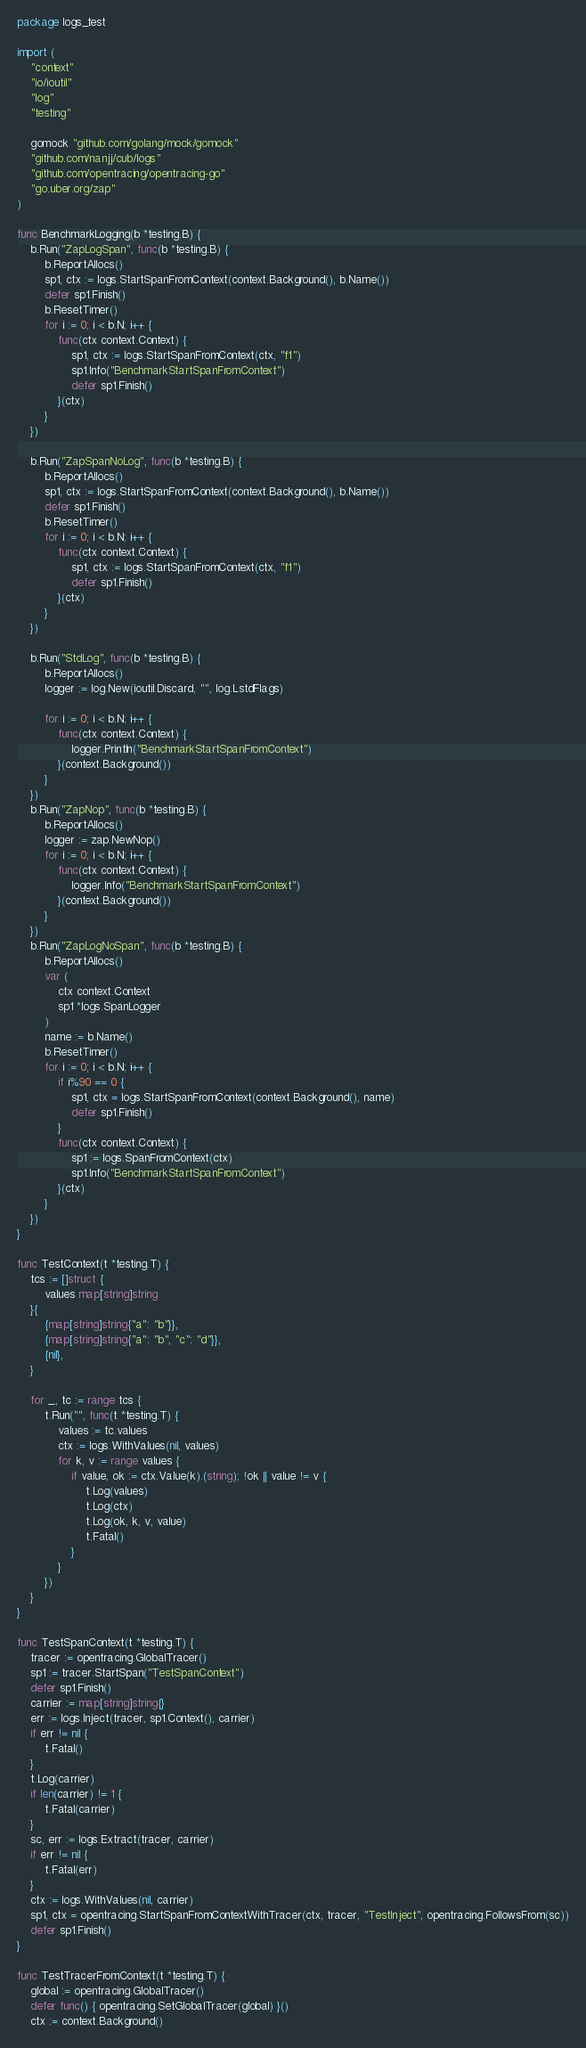Convert code to text. <code><loc_0><loc_0><loc_500><loc_500><_Go_>package logs_test

import (
	"context"
	"io/ioutil"
	"log"
	"testing"

	gomock "github.com/golang/mock/gomock"
	"github.com/nanjj/cub/logs"
	"github.com/opentracing/opentracing-go"
	"go.uber.org/zap"
)

func BenchmarkLogging(b *testing.B) {
	b.Run("ZapLogSpan", func(b *testing.B) {
		b.ReportAllocs()
		sp1, ctx := logs.StartSpanFromContext(context.Background(), b.Name())
		defer sp1.Finish()
		b.ResetTimer()
		for i := 0; i < b.N; i++ {
			func(ctx context.Context) {
				sp1, ctx := logs.StartSpanFromContext(ctx, "f1")
				sp1.Info("BenchmarkStartSpanFromContext")
				defer sp1.Finish()
			}(ctx)
		}
	})

	b.Run("ZapSpanNoLog", func(b *testing.B) {
		b.ReportAllocs()
		sp1, ctx := logs.StartSpanFromContext(context.Background(), b.Name())
		defer sp1.Finish()
		b.ResetTimer()
		for i := 0; i < b.N; i++ {
			func(ctx context.Context) {
				sp1, ctx := logs.StartSpanFromContext(ctx, "f1")
				defer sp1.Finish()
			}(ctx)
		}
	})

	b.Run("StdLog", func(b *testing.B) {
		b.ReportAllocs()
		logger := log.New(ioutil.Discard, "", log.LstdFlags)

		for i := 0; i < b.N; i++ {
			func(ctx context.Context) {
				logger.Println("BenchmarkStartSpanFromContext")
			}(context.Background())
		}
	})
	b.Run("ZapNop", func(b *testing.B) {
		b.ReportAllocs()
		logger := zap.NewNop()
		for i := 0; i < b.N; i++ {
			func(ctx context.Context) {
				logger.Info("BenchmarkStartSpanFromContext")
			}(context.Background())
		}
	})
	b.Run("ZapLogNoSpan", func(b *testing.B) {
		b.ReportAllocs()
		var (
			ctx context.Context
			sp1 *logs.SpanLogger
		)
		name := b.Name()
		b.ResetTimer()
		for i := 0; i < b.N; i++ {
			if i%90 == 0 {
				sp1, ctx = logs.StartSpanFromContext(context.Background(), name)
				defer sp1.Finish()
			}
			func(ctx context.Context) {
				sp1 := logs.SpanFromContext(ctx)
				sp1.Info("BenchmarkStartSpanFromContext")
			}(ctx)
		}
	})
}

func TestContext(t *testing.T) {
	tcs := []struct {
		values map[string]string
	}{
		{map[string]string{"a": "b"}},
		{map[string]string{"a": "b", "c": "d"}},
		{nil},
	}

	for _, tc := range tcs {
		t.Run("", func(t *testing.T) {
			values := tc.values
			ctx := logs.WithValues(nil, values)
			for k, v := range values {
				if value, ok := ctx.Value(k).(string); !ok || value != v {
					t.Log(values)
					t.Log(ctx)
					t.Log(ok, k, v, value)
					t.Fatal()
				}
			}
		})
	}
}

func TestSpanContext(t *testing.T) {
	tracer := opentracing.GlobalTracer()
	sp1 := tracer.StartSpan("TestSpanContext")
	defer sp1.Finish()
	carrier := map[string]string{}
	err := logs.Inject(tracer, sp1.Context(), carrier)
	if err != nil {
		t.Fatal()
	}
	t.Log(carrier)
	if len(carrier) != 1 {
		t.Fatal(carrier)
	}
	sc, err := logs.Extract(tracer, carrier)
	if err != nil {
		t.Fatal(err)
	}
	ctx := logs.WithValues(nil, carrier)
	sp1, ctx = opentracing.StartSpanFromContextWithTracer(ctx, tracer, "TestInject", opentracing.FollowsFrom(sc))
	defer sp1.Finish()
}

func TestTracerFromContext(t *testing.T) {
	global := opentracing.GlobalTracer()
	defer func() { opentracing.SetGlobalTracer(global) }()
	ctx := context.Background()</code> 